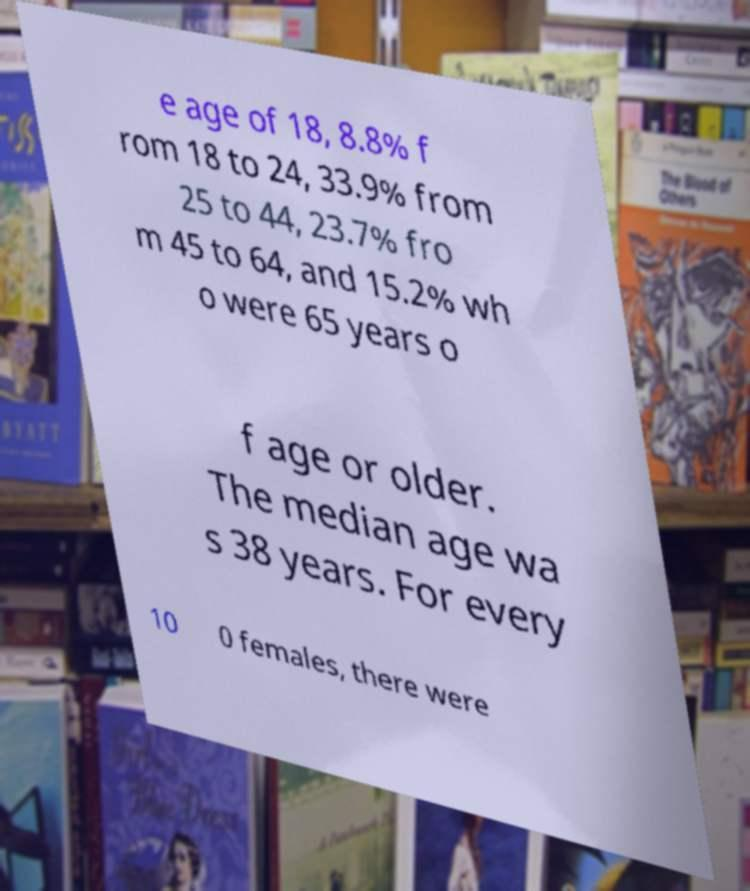Can you read and provide the text displayed in the image?This photo seems to have some interesting text. Can you extract and type it out for me? e age of 18, 8.8% f rom 18 to 24, 33.9% from 25 to 44, 23.7% fro m 45 to 64, and 15.2% wh o were 65 years o f age or older. The median age wa s 38 years. For every 10 0 females, there were 